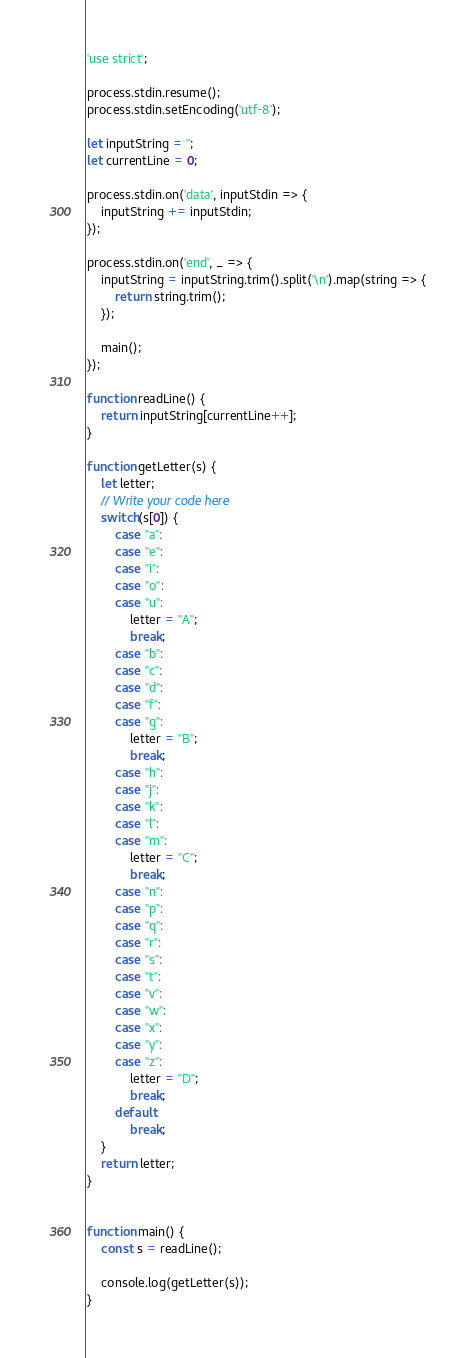<code> <loc_0><loc_0><loc_500><loc_500><_JavaScript_>'use strict';

process.stdin.resume();
process.stdin.setEncoding('utf-8');

let inputString = '';
let currentLine = 0;

process.stdin.on('data', inputStdin => {
    inputString += inputStdin;
});

process.stdin.on('end', _ => {
    inputString = inputString.trim().split('\n').map(string => {
        return string.trim();
    });
    
    main();    
});

function readLine() {
    return inputString[currentLine++];
}

function getLetter(s) {
    let letter;
    // Write your code here
    switch(s[0]) {
        case "a":
        case "e":
        case "i":
        case "o":
        case "u":
            letter = "A";
            break;
        case "b":
        case "c":
        case "d":
        case "f":
        case "g":
            letter = "B";
            break;
        case "h":
        case "j":
        case "k":
        case "l":
        case "m":
            letter = "C";
            break;
        case "n":
        case "p":
        case "q":
        case "r":
        case "s":
        case "t":
        case "v":
        case "w":
        case "x":
        case "y":
        case "z":
            letter = "D";
            break;
        default:
            break;
    }
    return letter;
}


function main() {
    const s = readLine();
    
    console.log(getLetter(s));
}
</code> 